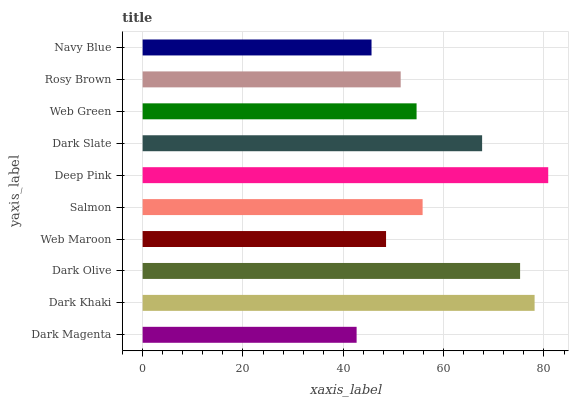Is Dark Magenta the minimum?
Answer yes or no. Yes. Is Deep Pink the maximum?
Answer yes or no. Yes. Is Dark Khaki the minimum?
Answer yes or no. No. Is Dark Khaki the maximum?
Answer yes or no. No. Is Dark Khaki greater than Dark Magenta?
Answer yes or no. Yes. Is Dark Magenta less than Dark Khaki?
Answer yes or no. Yes. Is Dark Magenta greater than Dark Khaki?
Answer yes or no. No. Is Dark Khaki less than Dark Magenta?
Answer yes or no. No. Is Salmon the high median?
Answer yes or no. Yes. Is Web Green the low median?
Answer yes or no. Yes. Is Dark Olive the high median?
Answer yes or no. No. Is Dark Slate the low median?
Answer yes or no. No. 